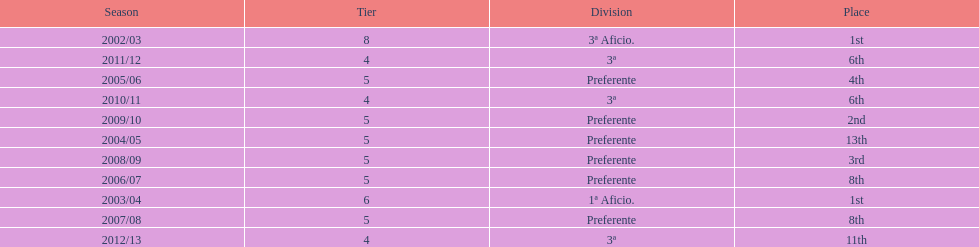How long did the team stay in first place? 2 years. 